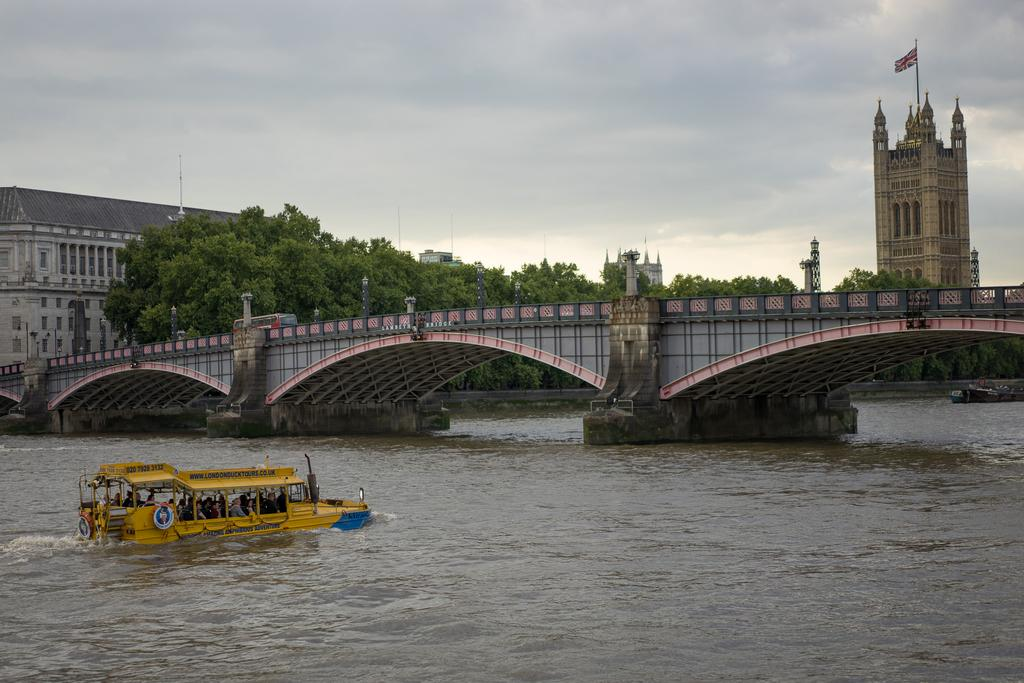What is in the water in the image? There is a boat in the water in the image. Who is in the boat? There are people in the boat. What can be seen in the background of the image? There is a bridge, many trees, and buildings in the image. What is attached to the bridge in the image? There is a flag attached to the bridge in the image. How would you describe the weather in the image? The sky is cloudy in the image. What type of work is being done by the people in the boat in the image? There is no indication of work being done by the people in the boat in the image. 